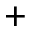<formula> <loc_0><loc_0><loc_500><loc_500>^ { + }</formula> 